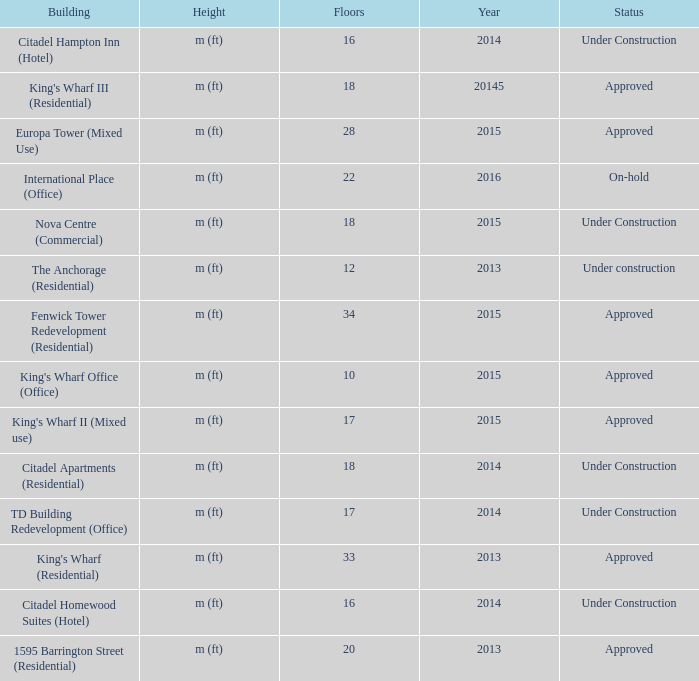What is the status of the building for 2014 with 33 floors? Approved. 